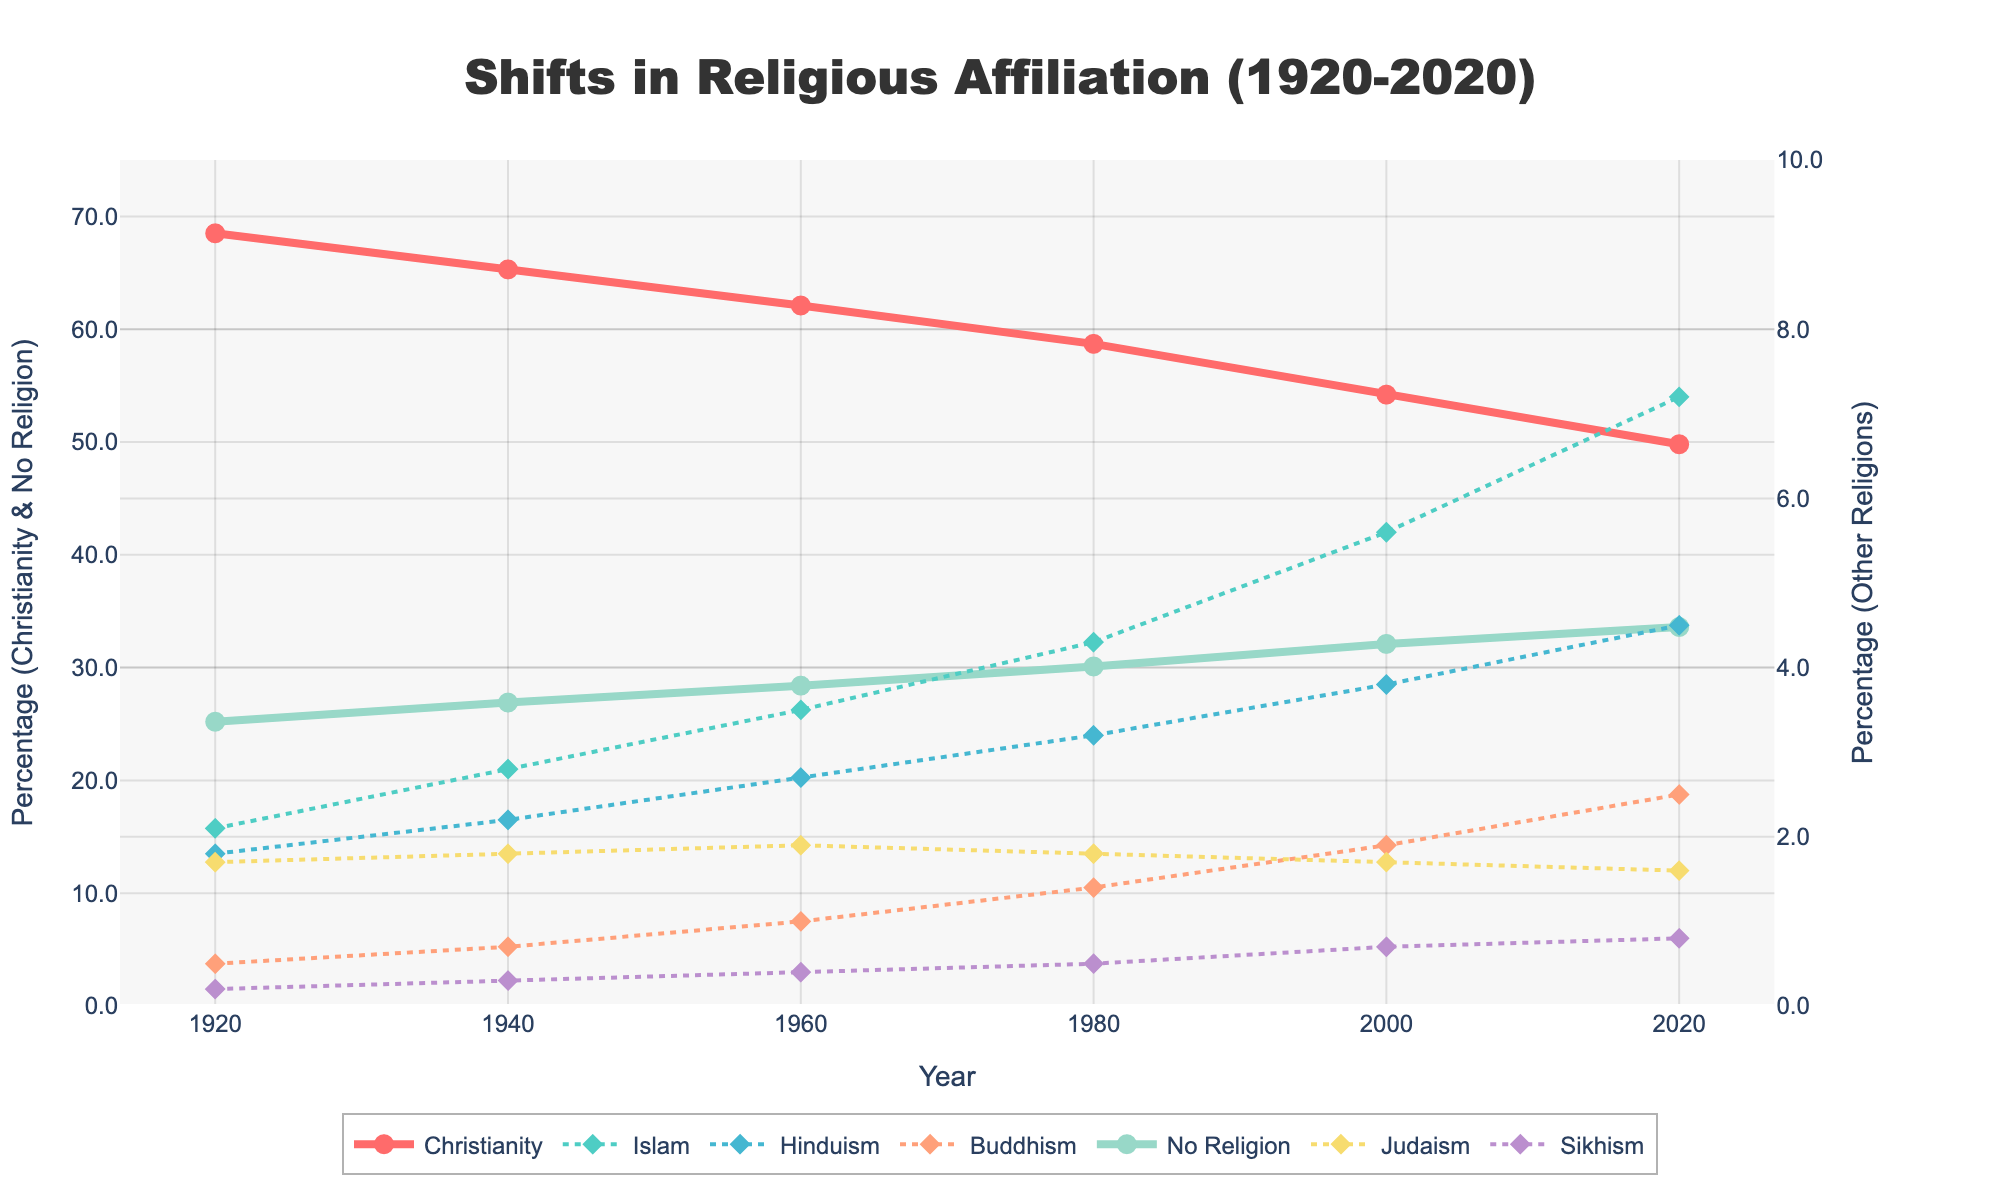What is the overall trend of Christianity from 1920 to 2020? The plot shows the percentage of Christianity decreasing from 68.5% in 1920 to 49.8% in 2020. This indicates a downward trend over the century.
Answer: Decreasing Which religion shows the highest increase in affiliation from 1920 to 2020? By observing the ending values and initial values, Islam increased from 2.1% in 1920 to 7.2% in 2020, showing the highest increase.
Answer: Islam What has been the change in the percentage of people with no religious affiliation from 1920 to 2020? The percentage increased from 25.2% in 1920 to 33.6% in 2020. The change is calculated as 33.6% - 25.2% = 8.4%.
Answer: 8.4% Which two religions had nearly equal percentages in 1940? The chart shows that in 1940, Hinduism and No Religion had nearly the same percentages: Hinduism at 2.2% and No Religion at 26.9%.
Answer: Hinduism and No Religion How many percentage points did Buddhism increase from 1920 to 2020? In 1920, Buddhism was at 0.5% and increased to 2.5% by 2020. Therefore, the increase is 2.5% - 0.5% = 2%.
Answer: 2% Rank the religions by their percentages in 2020 from highest to lowest. The chart shows, from highest to lowest in 2020: No Religion (33.6%), Christianity (49.8%), Islam (7.2%), Hinduism (4.5%), Buddhism (2.5%), Judaism (1.6%), Sikhism (0.8%).
Answer: Christianity, No Religion, Islam, Hinduism, Buddhism, Judaism, Sikhism Which religion had a more significant percentage increase: Islam or Hinduism? Islam increased from 2.1% in 1920 to 7.2% in 2020. Hinduism increased from 1.8% in 1920 to 4.5% in 2020. Calculating the differences, Islam increased by 5.1% and Hinduism by 2.7%.
Answer: Islam What can be said about Judaism’s trend over the century? The percentage of Judaism remains relatively stable, with a slight initial increase from 1.7% in 1920 to 1.9% in 1960, followed by a slight decrease to 1.6% by 2020.
Answer: Stable with slight variations What was the percentage difference between Christianity and No Religion in 1980? In 1980, Christianity was at 58.7% and No Religion was at 30.1%. The percentage difference is 58.7% - 30.1% = 28.6%.
Answer: 28.6% Which religion had the smallest relative change in affiliation over the century? Sikhism started at 0.2% in 1920 and ended at 0.8% in 2020, meaning it had a total change of 0.6 percentage points. Since this is the smallest absolute change among all religions, Sikhism had the smallest relative change.
Answer: Sikhism 